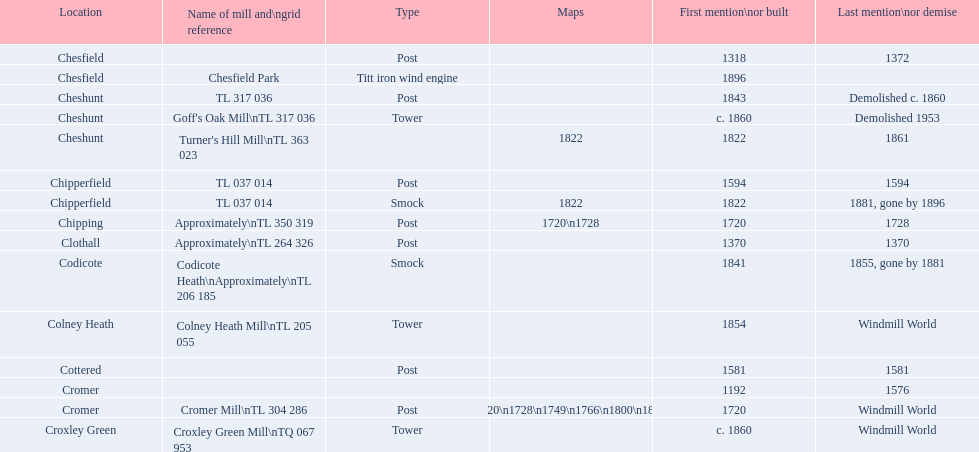Which place holds the highest number of maps? Cromer. 